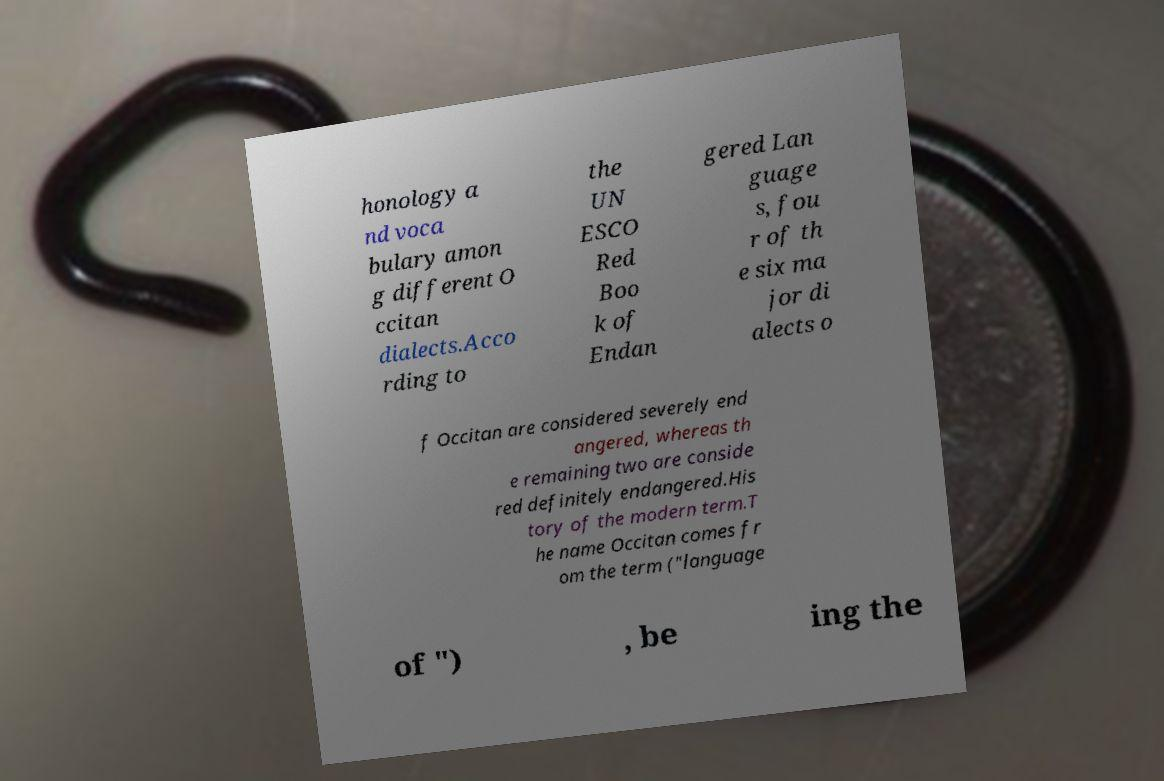I need the written content from this picture converted into text. Can you do that? honology a nd voca bulary amon g different O ccitan dialects.Acco rding to the UN ESCO Red Boo k of Endan gered Lan guage s, fou r of th e six ma jor di alects o f Occitan are considered severely end angered, whereas th e remaining two are conside red definitely endangered.His tory of the modern term.T he name Occitan comes fr om the term ("language of ") , be ing the 